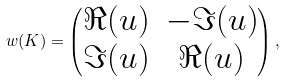Convert formula to latex. <formula><loc_0><loc_0><loc_500><loc_500>w ( K ) = \begin{pmatrix} \Re ( u ) & - \Im ( u ) \\ \Im ( u ) & \Re ( u ) \end{pmatrix} ,</formula> 